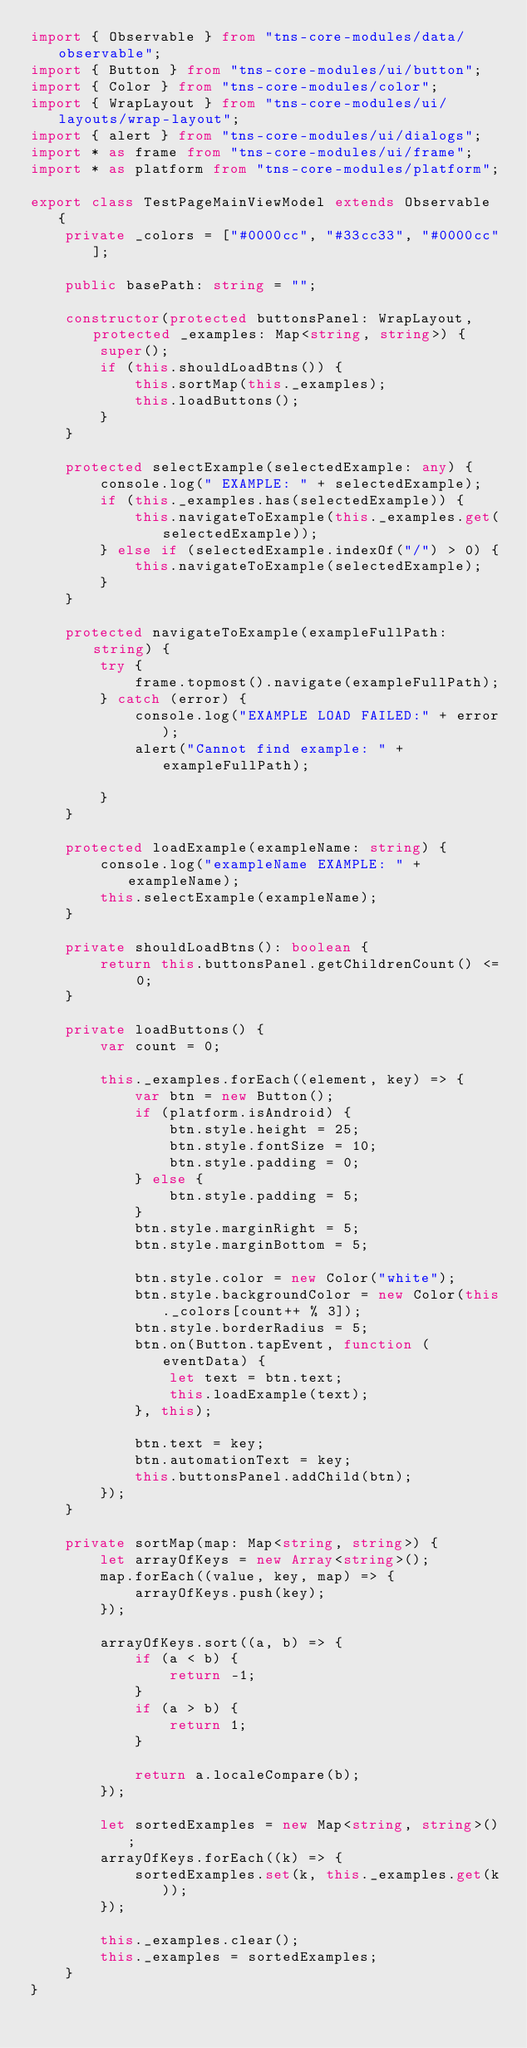<code> <loc_0><loc_0><loc_500><loc_500><_TypeScript_>import { Observable } from "tns-core-modules/data/observable";
import { Button } from "tns-core-modules/ui/button";
import { Color } from "tns-core-modules/color";
import { WrapLayout } from "tns-core-modules/ui/layouts/wrap-layout";
import { alert } from "tns-core-modules/ui/dialogs";
import * as frame from "tns-core-modules/ui/frame";
import * as platform from "tns-core-modules/platform";

export class TestPageMainViewModel extends Observable {
    private _colors = ["#0000cc", "#33cc33", "#0000cc"];

    public basePath: string = "";

    constructor(protected buttonsPanel: WrapLayout, protected _examples: Map<string, string>) {
        super();
        if (this.shouldLoadBtns()) {
            this.sortMap(this._examples);
            this.loadButtons();
        }
    }

    protected selectExample(selectedExample: any) {
        console.log(" EXAMPLE: " + selectedExample);
        if (this._examples.has(selectedExample)) {
            this.navigateToExample(this._examples.get(selectedExample));
        } else if (selectedExample.indexOf("/") > 0) {
            this.navigateToExample(selectedExample);
        }
    }

    protected navigateToExample(exampleFullPath: string) {
        try {
            frame.topmost().navigate(exampleFullPath);
        } catch (error) {
            console.log("EXAMPLE LOAD FAILED:" + error);
            alert("Cannot find example: " + exampleFullPath);

        }
    }

    protected loadExample(exampleName: string) {
        console.log("exampleName EXAMPLE: " + exampleName);
        this.selectExample(exampleName);
    }

    private shouldLoadBtns(): boolean {
        return this.buttonsPanel.getChildrenCount() <= 0;
    }

    private loadButtons() {
        var count = 0;

        this._examples.forEach((element, key) => {
            var btn = new Button();
            if (platform.isAndroid) {
                btn.style.height = 25;
                btn.style.fontSize = 10;
                btn.style.padding = 0;
            } else {
                btn.style.padding = 5;
            }
            btn.style.marginRight = 5;
            btn.style.marginBottom = 5;

            btn.style.color = new Color("white");
            btn.style.backgroundColor = new Color(this._colors[count++ % 3]);
            btn.style.borderRadius = 5;
            btn.on(Button.tapEvent, function (eventData) {
                let text = btn.text;
                this.loadExample(text);
            }, this);

            btn.text = key;
            btn.automationText = key;
            this.buttonsPanel.addChild(btn);
        });
    }

    private sortMap(map: Map<string, string>) {
        let arrayOfKeys = new Array<string>();
        map.forEach((value, key, map) => {
            arrayOfKeys.push(key);
        });

        arrayOfKeys.sort((a, b) => {
            if (a < b) {
                return -1;
            }
            if (a > b) {
                return 1;
            }

            return a.localeCompare(b);
        });

        let sortedExamples = new Map<string, string>();
        arrayOfKeys.forEach((k) => {
            sortedExamples.set(k, this._examples.get(k));
        });

        this._examples.clear();
        this._examples = sortedExamples;
    }
}
</code> 